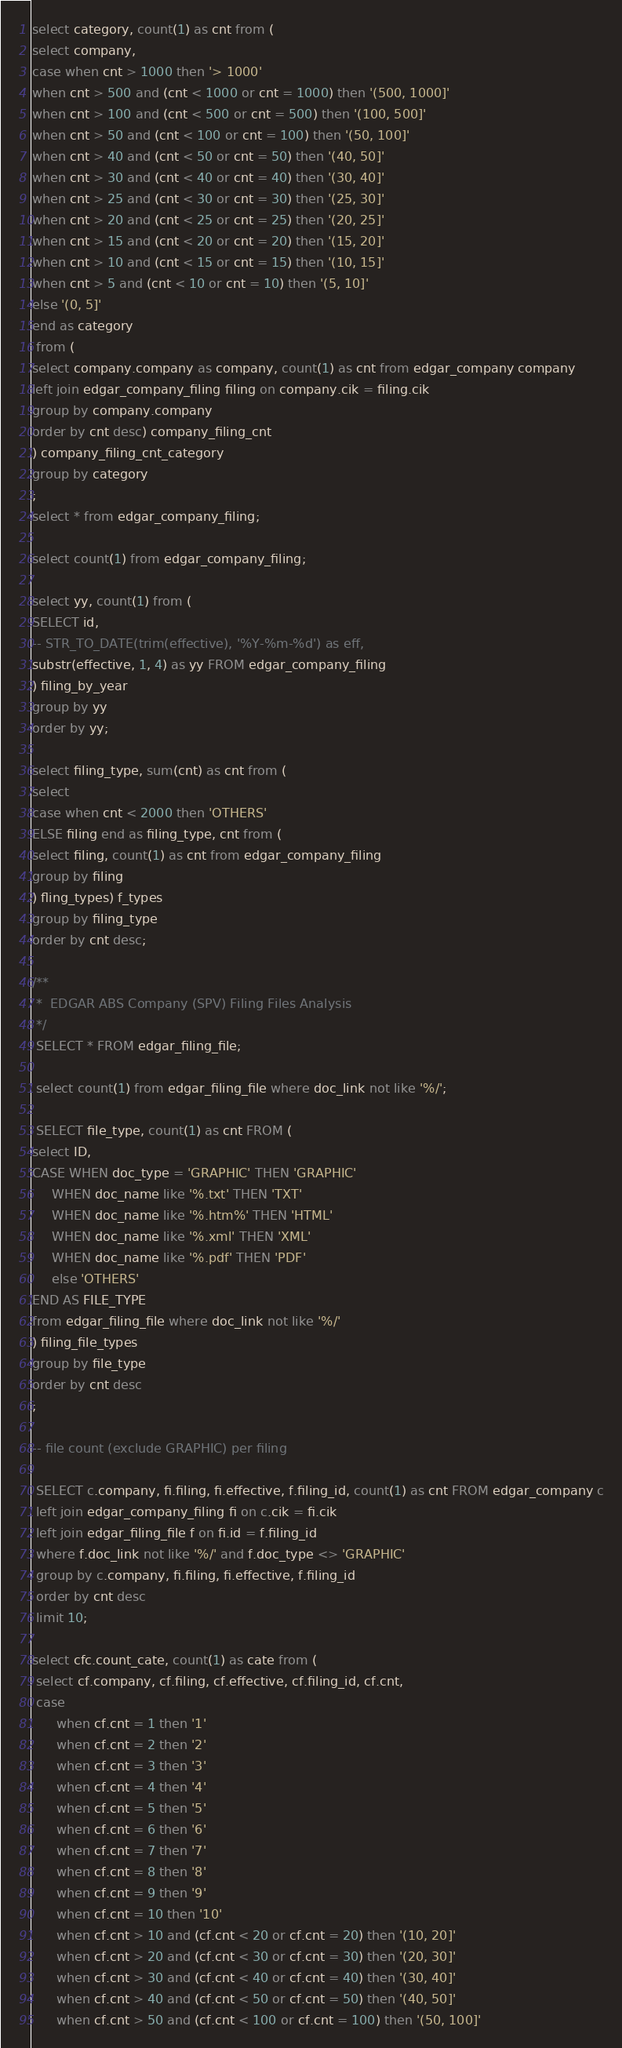Convert code to text. <code><loc_0><loc_0><loc_500><loc_500><_SQL_>select category, count(1) as cnt from (
select company,
case when cnt > 1000 then '> 1000'
when cnt > 500 and (cnt < 1000 or cnt = 1000) then '(500, 1000]'
when cnt > 100 and (cnt < 500 or cnt = 500) then '(100, 500]'
when cnt > 50 and (cnt < 100 or cnt = 100) then '(50, 100]'
when cnt > 40 and (cnt < 50 or cnt = 50) then '(40, 50]'
when cnt > 30 and (cnt < 40 or cnt = 40) then '(30, 40]'
when cnt > 25 and (cnt < 30 or cnt = 30) then '(25, 30]'
when cnt > 20 and (cnt < 25 or cnt = 25) then '(20, 25]'
when cnt > 15 and (cnt < 20 or cnt = 20) then '(15, 20]'
when cnt > 10 and (cnt < 15 or cnt = 15) then '(10, 15]'
when cnt > 5 and (cnt < 10 or cnt = 10) then '(5, 10]'
else '(0, 5]'
end as category
 from (
select company.company as company, count(1) as cnt from edgar_company company
left join edgar_company_filing filing on company.cik = filing.cik
group by company.company
order by cnt desc) company_filing_cnt
) company_filing_cnt_category
group by category
;
select * from edgar_company_filing;

select count(1) from edgar_company_filing;

select yy, count(1) from (
SELECT id, 
-- STR_TO_DATE(trim(effective), '%Y-%m-%d') as eff, 
substr(effective, 1, 4) as yy FROM edgar_company_filing
) filing_by_year
group by yy
order by yy;

select filing_type, sum(cnt) as cnt from ( 
select
case when cnt < 2000 then 'OTHERS'
ELSE filing end as filing_type, cnt from (
select filing, count(1) as cnt from edgar_company_filing 
group by filing
) fling_types) f_types
group by filing_type
order by cnt desc;

/**
 *  EDGAR ABS Company (SPV) Filing Files Analysis
 */
 SELECT * FROM edgar_filing_file;
 
 select count(1) from edgar_filing_file where doc_link not like '%/';
 
 SELECT file_type, count(1) as cnt FROM (
select ID, 
CASE WHEN doc_type = 'GRAPHIC' THEN 'GRAPHIC'
	 WHEN doc_name like '%.txt' THEN 'TXT'
     WHEN doc_name like '%.htm%' THEN 'HTML'
     WHEN doc_name like '%.xml' THEN 'XML'
     WHEN doc_name like '%.pdf' THEN 'PDF'
     else 'OTHERS'
END AS FILE_TYPE
from edgar_filing_file where doc_link not like '%/'
) filing_file_types
group by file_type
order by cnt desc
;
 
-- file count (exclude GRAPHIC) per filing
 
 SELECT c.company, fi.filing, fi.effective, f.filing_id, count(1) as cnt FROM edgar_company c
 left join edgar_company_filing fi on c.cik = fi.cik
 left join edgar_filing_file f on fi.id = f.filing_id
 where f.doc_link not like '%/' and f.doc_type <> 'GRAPHIC'
 group by c.company, fi.filing, fi.effective, f.filing_id
 order by cnt desc
 limit 10;
 
select cfc.count_cate, count(1) as cate from (
 select cf.company, cf.filing, cf.effective, cf.filing_id, cf.cnt,
 case 
	  when cf.cnt = 1 then '1'
      when cf.cnt = 2 then '2'
      when cf.cnt = 3 then '3'
      when cf.cnt = 4 then '4'
      when cf.cnt = 5 then '5'
      when cf.cnt = 6 then '6'
      when cf.cnt = 7 then '7'
      when cf.cnt = 8 then '8'
      when cf.cnt = 9 then '9'
      when cf.cnt = 10 then '10'
	  when cf.cnt > 10 and (cf.cnt < 20 or cf.cnt = 20) then '(10, 20]'
      when cf.cnt > 20 and (cf.cnt < 30 or cf.cnt = 30) then '(20, 30]'
      when cf.cnt > 30 and (cf.cnt < 40 or cf.cnt = 40) then '(30, 40]'
      when cf.cnt > 40 and (cf.cnt < 50 or cf.cnt = 50) then '(40, 50]'
      when cf.cnt > 50 and (cf.cnt < 100 or cf.cnt = 100) then '(50, 100]'</code> 